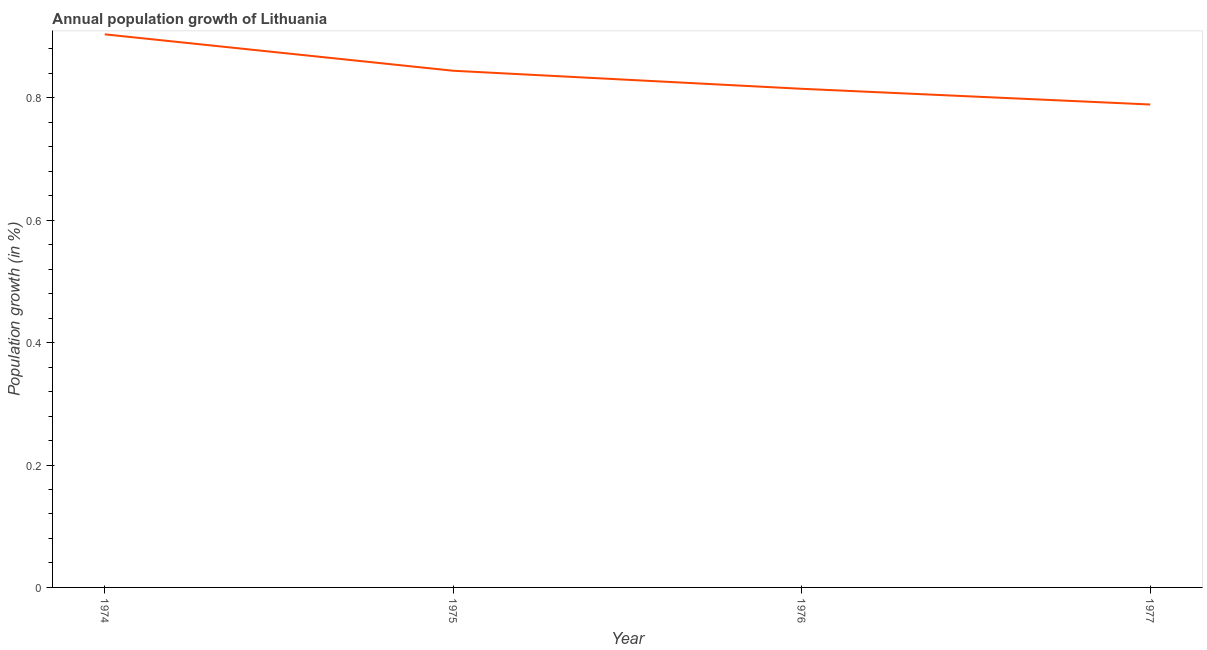What is the population growth in 1976?
Your response must be concise. 0.81. Across all years, what is the maximum population growth?
Your answer should be very brief. 0.9. Across all years, what is the minimum population growth?
Provide a succinct answer. 0.79. In which year was the population growth maximum?
Make the answer very short. 1974. In which year was the population growth minimum?
Offer a terse response. 1977. What is the sum of the population growth?
Offer a terse response. 3.35. What is the difference between the population growth in 1974 and 1975?
Give a very brief answer. 0.06. What is the average population growth per year?
Offer a very short reply. 0.84. What is the median population growth?
Offer a terse response. 0.83. In how many years, is the population growth greater than 0.52 %?
Make the answer very short. 4. Do a majority of the years between 1975 and 1974 (inclusive) have population growth greater than 0.4 %?
Keep it short and to the point. No. What is the ratio of the population growth in 1974 to that in 1977?
Offer a very short reply. 1.15. Is the population growth in 1974 less than that in 1975?
Your answer should be very brief. No. Is the difference between the population growth in 1976 and 1977 greater than the difference between any two years?
Offer a terse response. No. What is the difference between the highest and the second highest population growth?
Ensure brevity in your answer.  0.06. What is the difference between the highest and the lowest population growth?
Keep it short and to the point. 0.11. What is the difference between two consecutive major ticks on the Y-axis?
Offer a very short reply. 0.2. Are the values on the major ticks of Y-axis written in scientific E-notation?
Ensure brevity in your answer.  No. Does the graph contain grids?
Your answer should be compact. No. What is the title of the graph?
Ensure brevity in your answer.  Annual population growth of Lithuania. What is the label or title of the X-axis?
Offer a very short reply. Year. What is the label or title of the Y-axis?
Offer a terse response. Population growth (in %). What is the Population growth (in %) in 1974?
Provide a succinct answer. 0.9. What is the Population growth (in %) in 1975?
Your answer should be compact. 0.84. What is the Population growth (in %) of 1976?
Give a very brief answer. 0.81. What is the Population growth (in %) of 1977?
Make the answer very short. 0.79. What is the difference between the Population growth (in %) in 1974 and 1975?
Offer a very short reply. 0.06. What is the difference between the Population growth (in %) in 1974 and 1976?
Give a very brief answer. 0.09. What is the difference between the Population growth (in %) in 1974 and 1977?
Ensure brevity in your answer.  0.11. What is the difference between the Population growth (in %) in 1975 and 1976?
Give a very brief answer. 0.03. What is the difference between the Population growth (in %) in 1975 and 1977?
Offer a terse response. 0.06. What is the difference between the Population growth (in %) in 1976 and 1977?
Your answer should be very brief. 0.03. What is the ratio of the Population growth (in %) in 1974 to that in 1975?
Ensure brevity in your answer.  1.07. What is the ratio of the Population growth (in %) in 1974 to that in 1976?
Offer a terse response. 1.11. What is the ratio of the Population growth (in %) in 1974 to that in 1977?
Offer a very short reply. 1.15. What is the ratio of the Population growth (in %) in 1975 to that in 1976?
Your answer should be very brief. 1.04. What is the ratio of the Population growth (in %) in 1975 to that in 1977?
Provide a short and direct response. 1.07. What is the ratio of the Population growth (in %) in 1976 to that in 1977?
Keep it short and to the point. 1.03. 